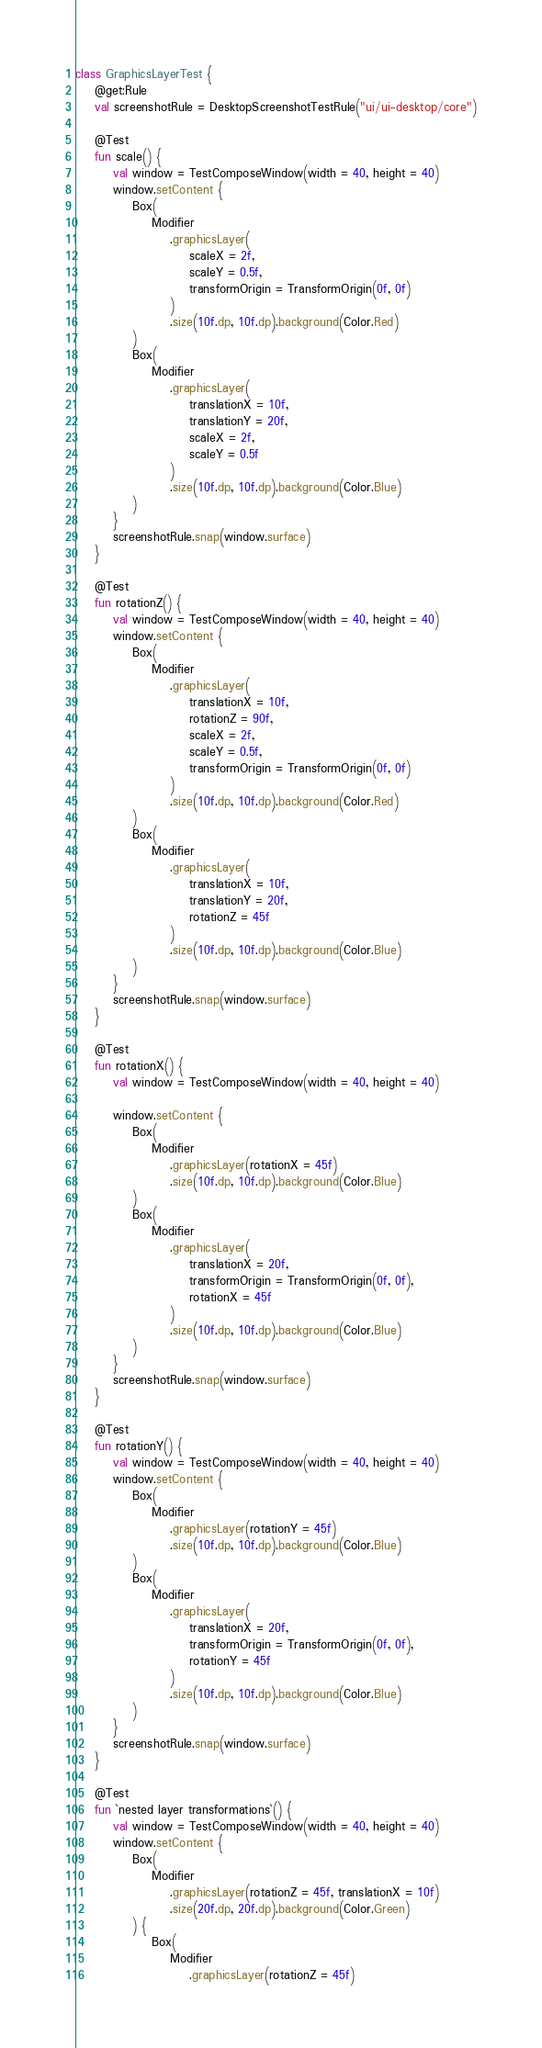Convert code to text. <code><loc_0><loc_0><loc_500><loc_500><_Kotlin_>class GraphicsLayerTest {
    @get:Rule
    val screenshotRule = DesktopScreenshotTestRule("ui/ui-desktop/core")

    @Test
    fun scale() {
        val window = TestComposeWindow(width = 40, height = 40)
        window.setContent {
            Box(
                Modifier
                    .graphicsLayer(
                        scaleX = 2f,
                        scaleY = 0.5f,
                        transformOrigin = TransformOrigin(0f, 0f)
                    )
                    .size(10f.dp, 10f.dp).background(Color.Red)
            )
            Box(
                Modifier
                    .graphicsLayer(
                        translationX = 10f,
                        translationY = 20f,
                        scaleX = 2f,
                        scaleY = 0.5f
                    )
                    .size(10f.dp, 10f.dp).background(Color.Blue)
            )
        }
        screenshotRule.snap(window.surface)
    }

    @Test
    fun rotationZ() {
        val window = TestComposeWindow(width = 40, height = 40)
        window.setContent {
            Box(
                Modifier
                    .graphicsLayer(
                        translationX = 10f,
                        rotationZ = 90f,
                        scaleX = 2f,
                        scaleY = 0.5f,
                        transformOrigin = TransformOrigin(0f, 0f)
                    )
                    .size(10f.dp, 10f.dp).background(Color.Red)
            )
            Box(
                Modifier
                    .graphicsLayer(
                        translationX = 10f,
                        translationY = 20f,
                        rotationZ = 45f
                    )
                    .size(10f.dp, 10f.dp).background(Color.Blue)
            )
        }
        screenshotRule.snap(window.surface)
    }

    @Test
    fun rotationX() {
        val window = TestComposeWindow(width = 40, height = 40)

        window.setContent {
            Box(
                Modifier
                    .graphicsLayer(rotationX = 45f)
                    .size(10f.dp, 10f.dp).background(Color.Blue)
            )
            Box(
                Modifier
                    .graphicsLayer(
                        translationX = 20f,
                        transformOrigin = TransformOrigin(0f, 0f),
                        rotationX = 45f
                    )
                    .size(10f.dp, 10f.dp).background(Color.Blue)
            )
        }
        screenshotRule.snap(window.surface)
    }

    @Test
    fun rotationY() {
        val window = TestComposeWindow(width = 40, height = 40)
        window.setContent {
            Box(
                Modifier
                    .graphicsLayer(rotationY = 45f)
                    .size(10f.dp, 10f.dp).background(Color.Blue)
            )
            Box(
                Modifier
                    .graphicsLayer(
                        translationX = 20f,
                        transformOrigin = TransformOrigin(0f, 0f),
                        rotationY = 45f
                    )
                    .size(10f.dp, 10f.dp).background(Color.Blue)
            )
        }
        screenshotRule.snap(window.surface)
    }

    @Test
    fun `nested layer transformations`() {
        val window = TestComposeWindow(width = 40, height = 40)
        window.setContent {
            Box(
                Modifier
                    .graphicsLayer(rotationZ = 45f, translationX = 10f)
                    .size(20f.dp, 20f.dp).background(Color.Green)
            ) {
                Box(
                    Modifier
                        .graphicsLayer(rotationZ = 45f)</code> 